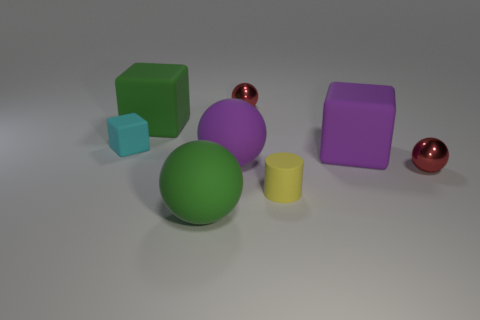How many balls are either cyan things or yellow things?
Offer a terse response. 0. How many spheres are there?
Keep it short and to the point. 4. There is a tiny yellow object; does it have the same shape as the thing behind the green matte block?
Ensure brevity in your answer.  No. There is a sphere in front of the small matte cylinder; how big is it?
Provide a short and direct response. Large. Does the large thing on the left side of the big green matte ball have the same shape as the tiny cyan object?
Provide a short and direct response. Yes. Is there a cylinder of the same size as the purple matte block?
Give a very brief answer. No. Is there a small sphere that is to the left of the large purple rubber object on the right side of the metal ball to the left of the small yellow cylinder?
Keep it short and to the point. Yes. What is the red sphere that is in front of the large rubber cube that is left of the tiny red object behind the cyan rubber cube made of?
Keep it short and to the point. Metal. There is a metal object that is to the left of the tiny rubber cylinder; what is its shape?
Your answer should be compact. Sphere. There is a purple sphere that is the same material as the small cyan cube; what is its size?
Your answer should be compact. Large. 